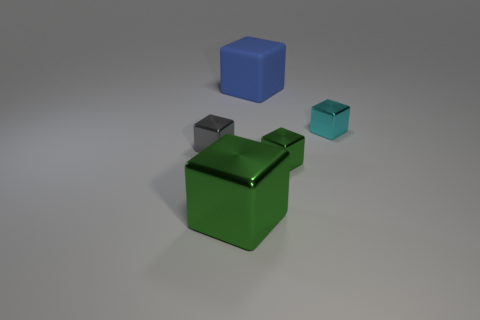Is the material of the green object right of the large green shiny thing the same as the cyan thing?
Your answer should be compact. Yes. Is there any other thing that is the same size as the gray metal block?
Your answer should be very brief. Yes. Are there fewer tiny metal cubes behind the large green block than big blocks to the left of the tiny gray object?
Provide a short and direct response. No. Is there any other thing that is the same shape as the large metal object?
Offer a very short reply. Yes. What material is the small thing that is the same color as the large shiny object?
Offer a terse response. Metal. What number of large blue cubes are behind the tiny cyan shiny cube to the right of the block that is in front of the small green metallic block?
Your answer should be compact. 1. There is a blue cube; how many big blue matte cubes are in front of it?
Offer a very short reply. 0. What number of other big things have the same material as the large green object?
Make the answer very short. 0. There is a large block that is made of the same material as the small cyan thing; what is its color?
Your answer should be compact. Green. There is a tiny thing that is to the left of the green thing right of the thing behind the cyan shiny object; what is it made of?
Your answer should be compact. Metal. 